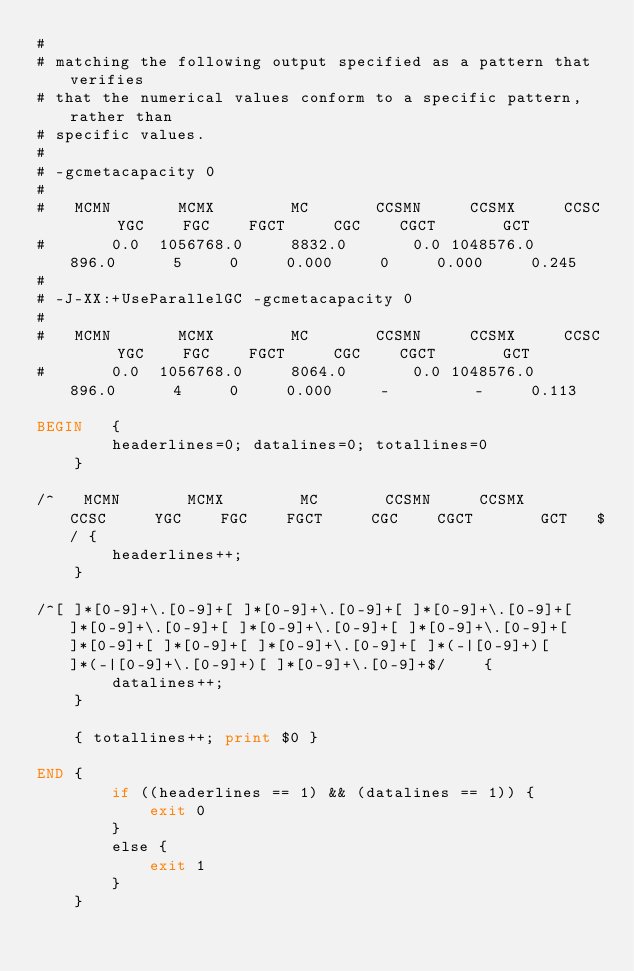<code> <loc_0><loc_0><loc_500><loc_500><_Awk_>#
# matching the following output specified as a pattern that verifies
# that the numerical values conform to a specific pattern, rather than
# specific values.
#
# -gcmetacapacity 0
#
#   MCMN       MCMX        MC       CCSMN     CCSMX     CCSC     YGC    FGC    FGCT     CGC    CGCT       GCT   
#       0.0  1056768.0     8832.0       0.0 1048576.0     896.0      5     0     0.000     0     0.000     0.245
#
# -J-XX:+UseParallelGC -gcmetacapacity 0
#
#   MCMN       MCMX        MC       CCSMN     CCSMX     CCSC     YGC    FGC    FGCT     CGC    CGCT       GCT   
#       0.0  1056768.0     8064.0       0.0 1048576.0     896.0      4     0     0.000     -         -     0.113

BEGIN	{
	    headerlines=0; datalines=0; totallines=0
	}

/^   MCMN       MCMX        MC       CCSMN     CCSMX     CCSC     YGC    FGC    FGCT     CGC    CGCT       GCT   $/	{
	    headerlines++;
	}

/^[ ]*[0-9]+\.[0-9]+[ ]*[0-9]+\.[0-9]+[ ]*[0-9]+\.[0-9]+[ ]*[0-9]+\.[0-9]+[ ]*[0-9]+\.[0-9]+[ ]*[0-9]+\.[0-9]+[ ]*[0-9]+[ ]*[0-9]+[ ]*[0-9]+\.[0-9]+[ ]*(-|[0-9]+)[ ]*(-|[0-9]+\.[0-9]+)[ ]*[0-9]+\.[0-9]+$/	{
	    datalines++;
	}

	{ totallines++; print $0 }

END	{
	    if ((headerlines == 1) && (datalines == 1)) {
	        exit 0
	    }
	    else {
	        exit 1
	    }
	}
</code> 